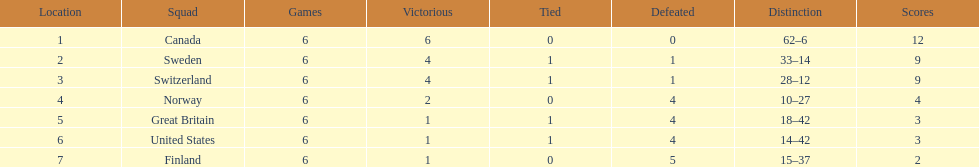What team placed after canada? Sweden. 